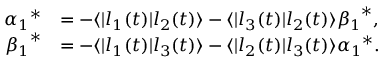Convert formula to latex. <formula><loc_0><loc_0><loc_500><loc_500>\begin{array} { r l } { { \alpha _ { 1 } } ^ { \ast } } & { = - \langle | l _ { 1 } ( t ) | l _ { 2 } ( t ) \rangle - \langle | l _ { 3 } ( t ) | l _ { 2 } ( t ) \rangle { \beta _ { 1 } } ^ { \ast } , } \\ { { \beta _ { 1 } } ^ { \ast } } & { = - \langle | l _ { 1 } ( t ) | l _ { 3 } ( t ) \rangle - \langle | l _ { 2 } ( t ) | l _ { 3 } ( t ) \rangle { \alpha _ { 1 } } ^ { \ast } . } \end{array}</formula> 